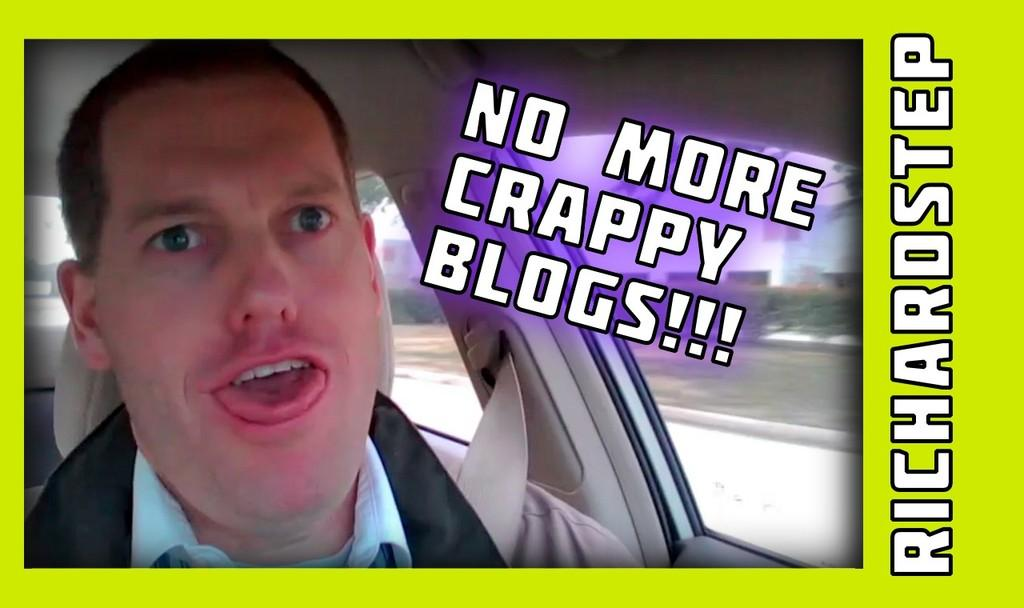What is the man in the image doing? The man is sitting inside a vehicle in the image. What can be seen in the image besides the man and the vehicle? There are plants and a building visible in the image. Are there any watermarks present in the image? Yes, the image has watermarks. What type of disease is the man suffering from in the image? There is no indication in the image that the man is suffering from any disease. 